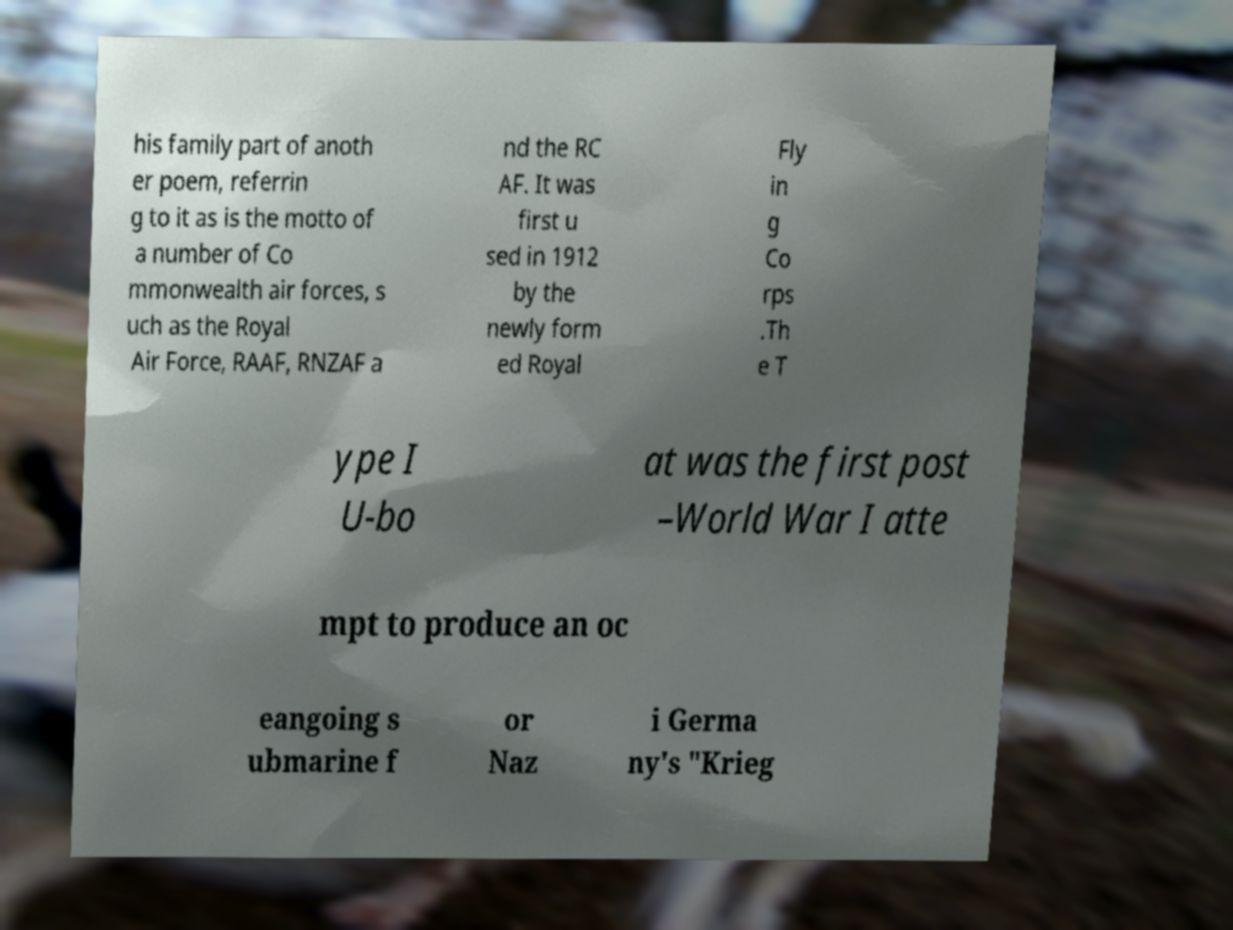Please identify and transcribe the text found in this image. his family part of anoth er poem, referrin g to it as is the motto of a number of Co mmonwealth air forces, s uch as the Royal Air Force, RAAF, RNZAF a nd the RC AF. It was first u sed in 1912 by the newly form ed Royal Fly in g Co rps .Th e T ype I U-bo at was the first post –World War I atte mpt to produce an oc eangoing s ubmarine f or Naz i Germa ny's "Krieg 